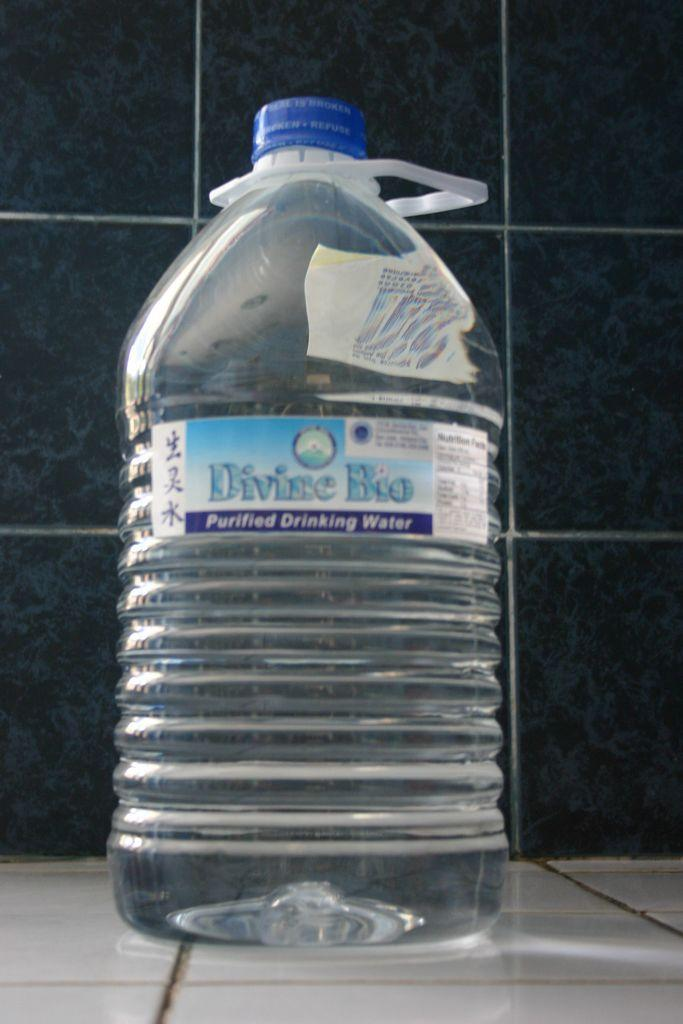<image>
Describe the image concisely. A large bottle of Divine Bio purified water sits on a tiled counter. 